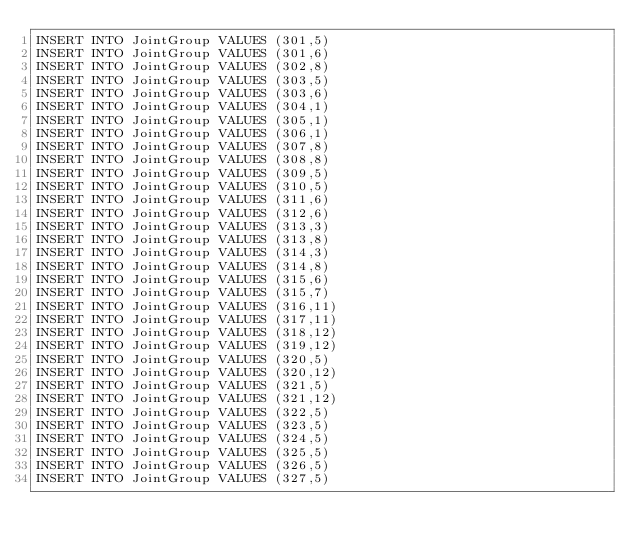<code> <loc_0><loc_0><loc_500><loc_500><_SQL_>INSERT INTO JointGroup VALUES (301,5)
INSERT INTO JointGroup VALUES (301,6)
INSERT INTO JointGroup VALUES (302,8)
INSERT INTO JointGroup VALUES (303,5)
INSERT INTO JointGroup VALUES (303,6)
INSERT INTO JointGroup VALUES (304,1)
INSERT INTO JointGroup VALUES (305,1)
INSERT INTO JointGroup VALUES (306,1)
INSERT INTO JointGroup VALUES (307,8)
INSERT INTO JointGroup VALUES (308,8)
INSERT INTO JointGroup VALUES (309,5)
INSERT INTO JointGroup VALUES (310,5)
INSERT INTO JointGroup VALUES (311,6)
INSERT INTO JointGroup VALUES (312,6)
INSERT INTO JointGroup VALUES (313,3)
INSERT INTO JointGroup VALUES (313,8)
INSERT INTO JointGroup VALUES (314,3)
INSERT INTO JointGroup VALUES (314,8)
INSERT INTO JointGroup VALUES (315,6)
INSERT INTO JointGroup VALUES (315,7)
INSERT INTO JointGroup VALUES (316,11)
INSERT INTO JointGroup VALUES (317,11)
INSERT INTO JointGroup VALUES (318,12)
INSERT INTO JointGroup VALUES (319,12)
INSERT INTO JointGroup VALUES (320,5)
INSERT INTO JointGroup VALUES (320,12)
INSERT INTO JointGroup VALUES (321,5)
INSERT INTO JointGroup VALUES (321,12)
INSERT INTO JointGroup VALUES (322,5)
INSERT INTO JointGroup VALUES (323,5)
INSERT INTO JointGroup VALUES (324,5)
INSERT INTO JointGroup VALUES (325,5)
INSERT INTO JointGroup VALUES (326,5)
INSERT INTO JointGroup VALUES (327,5)</code> 